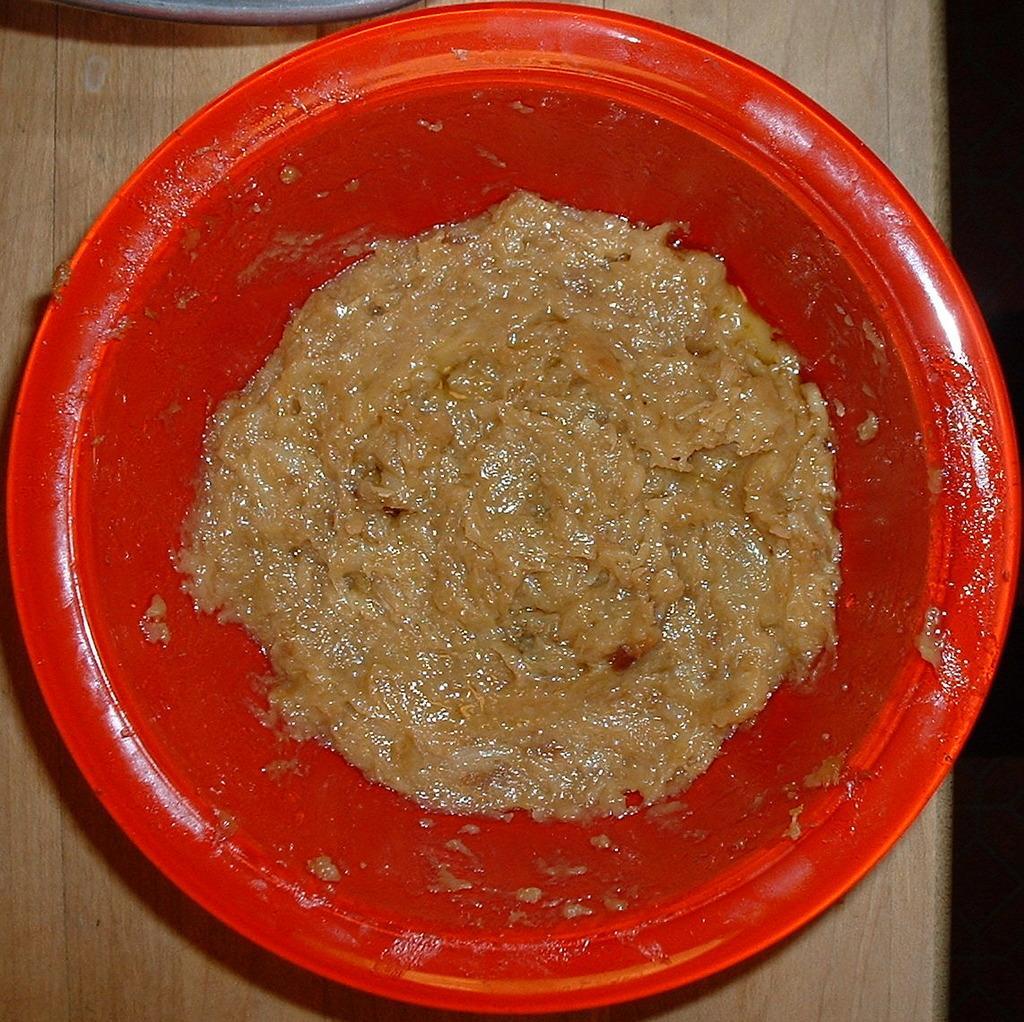Please provide a concise description of this image. In this image there is a red bowl and food. Red bowl is on the wooden surface. 